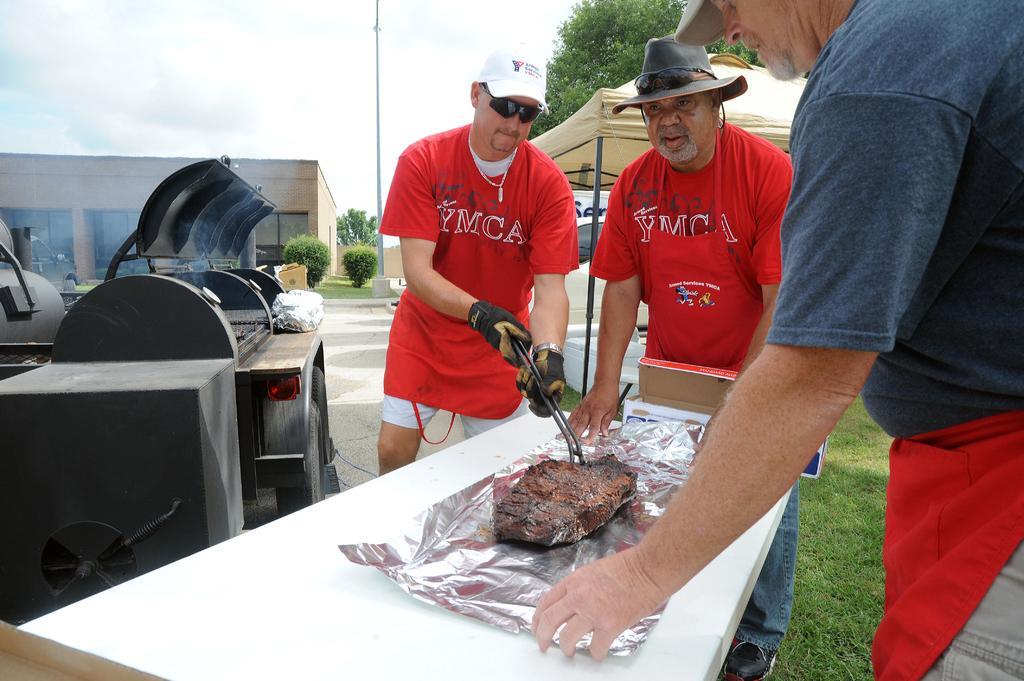Describe this image in one or two sentences. In this image there is a person holding some object. Beside him there are two other people standing on the grass. In front of them there is a table. On top of it there are some objects. On the left side of the image there are a few objects. In the background of the image there is a building. There are plants, trees and a pole. On the right side of the image there is a tent. There is a car. At the top of the image there are clouds in the sky. 